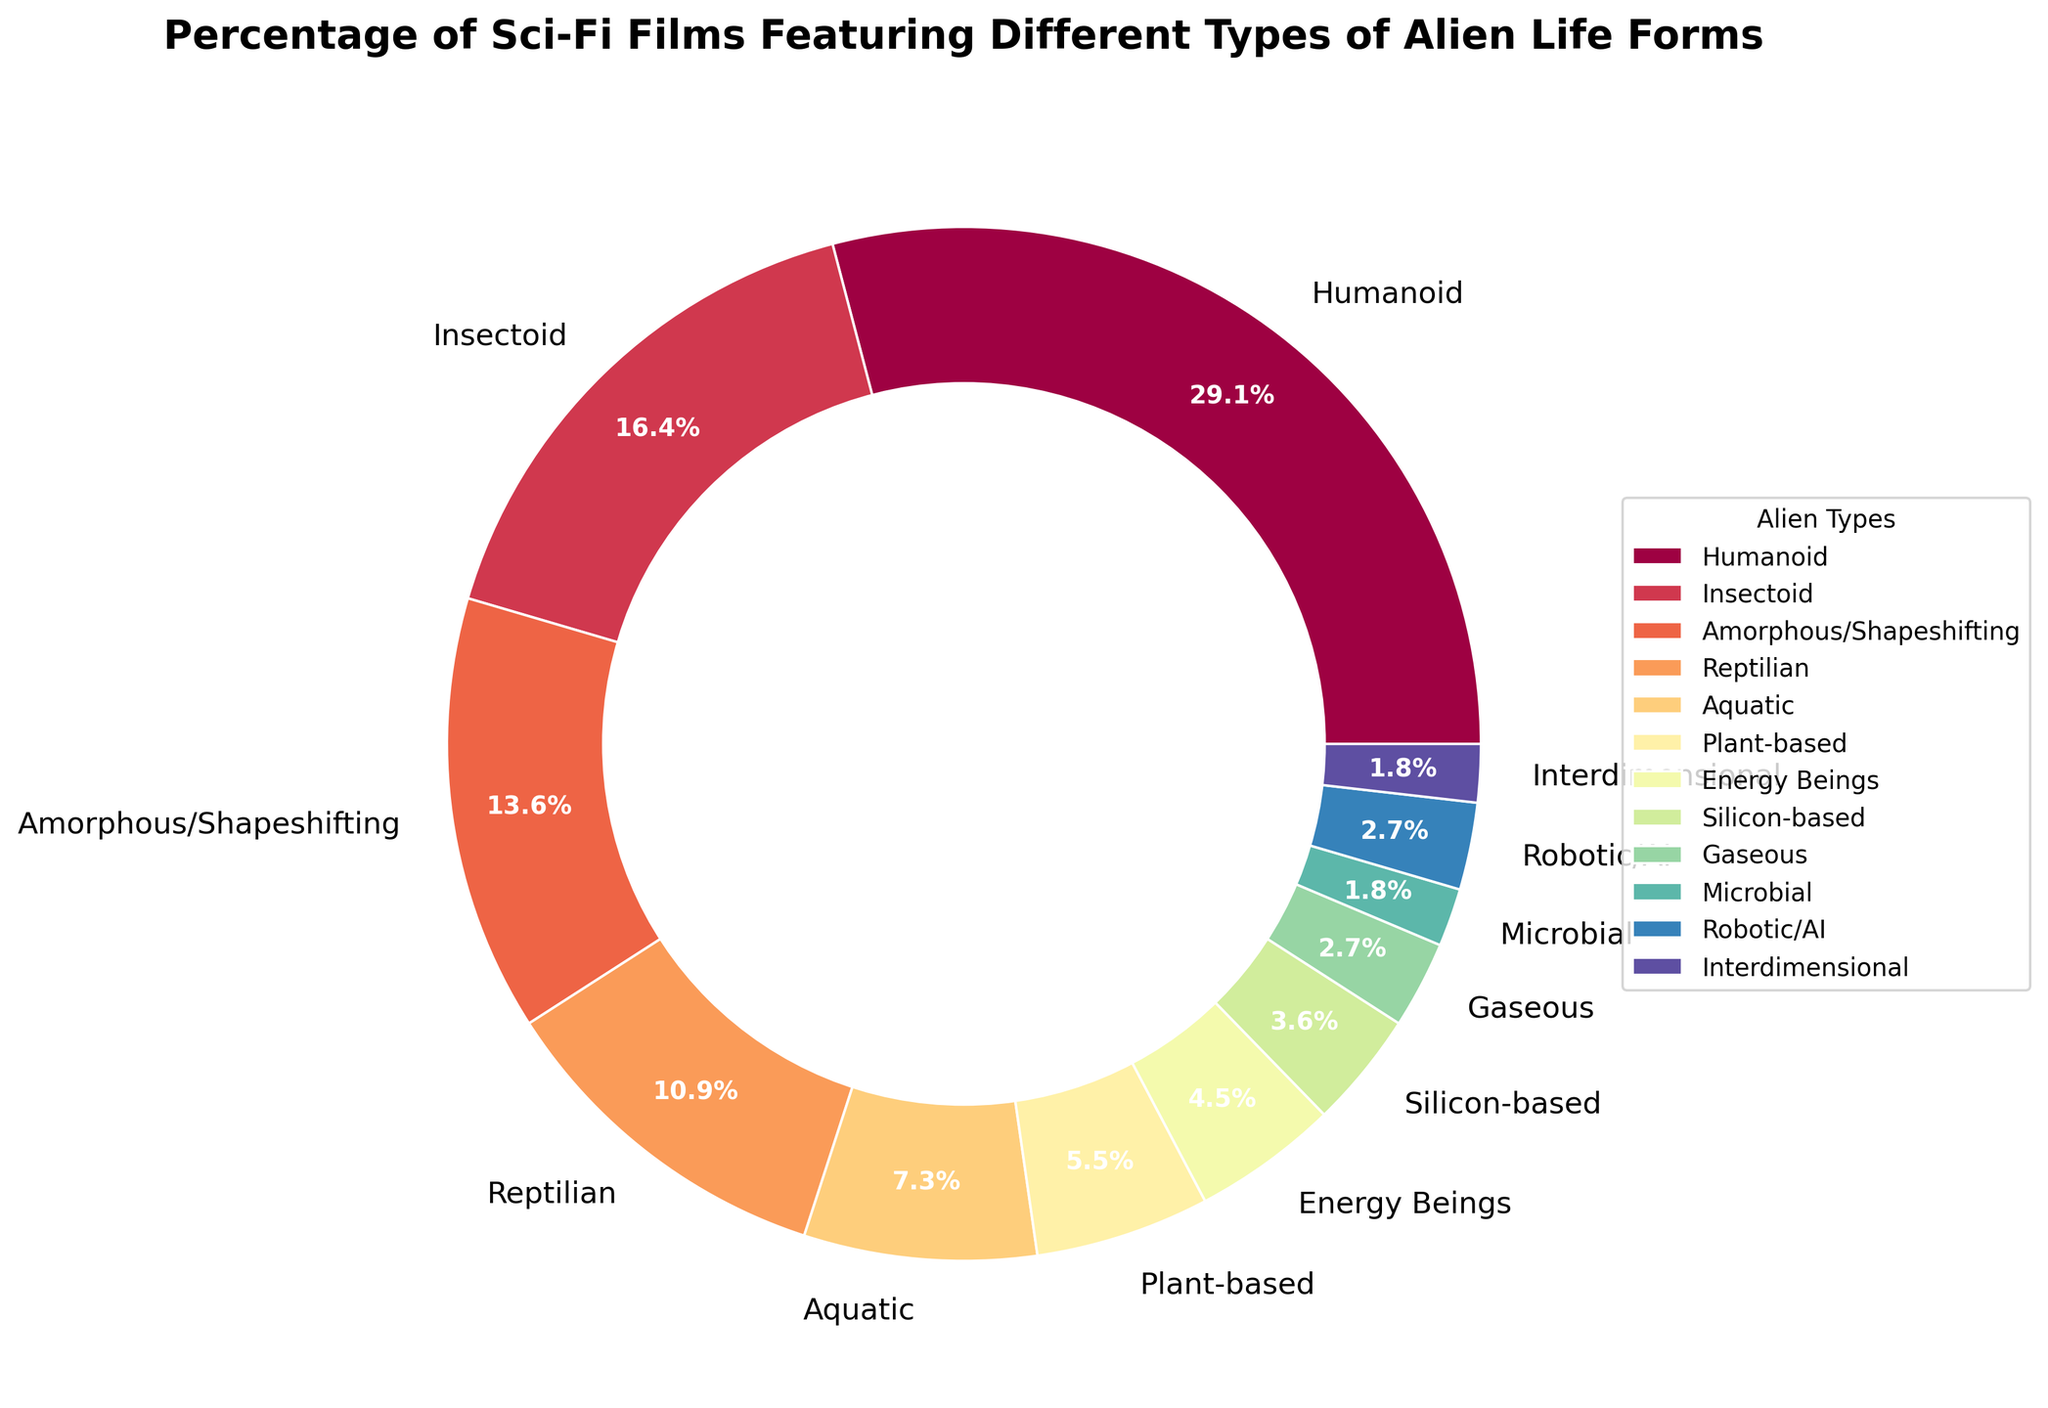What's the highest percentage of a specific type of alien life form featured in sci-fi films? The chart indicates different types of alien life forms and their respective percentages. By looking at the slices of the pie chart, the largest section represents Humanoid aliens with 32%.
Answer: 32% Which two types of alien life forms have similar percentages of appearance, each between 4% and 6%? By examining the chart, we can see that Plant-based and Energy Beings are within the 4%-6% range. Plant-based is 6%, and Energy Beings is 5%.
Answer: Plant-based and Energy Beings How much more prevalent are Humanoid aliens in sci-fi films compared to Reptilian aliens? Humanoid aliens have a percentage of 32%, while Reptilian aliens are at 12%. The difference between these two percentages is 32% - 12% = 20%.
Answer: 20% What's the total percentage of non-corporeal alien life forms shown (e.g., Energy Beings and Gaseous)? Energy Beings have 5% and Gaseous have 3%. Summing these, 5% + 3% = 8%.
Answer: 8% Do Aquatic aliens appear more frequently than Reptilian aliens? Comparing the segments for Aquatic (8%) and Reptilian (12%) life forms, it is evident that Reptilian aliens have a larger percentage.
Answer: No What's the combined percentage of the top three most common alien life forms in sci-fi films? The top three percentages are for Humanoid (32%), Insectoid (18%), and Amorphous/Shapeshifting (15%). Summing these gives: 32% + 18% + 15% = 65%.
Answer: 65% Which type of alien life form is the least frequent in these sci-fi films? The smallest slice of the pie chart represents Microbial aliens with 2%.
Answer: Microbial Considering all alien types with percentages above 10%, calculate their total percentage. The alien types with percentages above 10% are Humanoid (32%), Insectoid (18%), and Amorphous/Shapeshifting (15%), and Reptilian (12%). Summing these yields: 32% + 18% + 15% + 12% = 77%.
Answer: 77% Are there more films featuring Insectoid or Amorphous/Shapeshifting aliens? By comparing the slices, Insectoid aliens have 18% while Amorphous/Shapeshifting have 15%. Thus, Insectoid aliens appear more frequently.
Answer: Insectoid Which alien life form types have a percentage below 5%, and what is their combined percentage? The types below 5% are Silicon-based (4%), Gaseous (3%), Microbial (2%), Robotic/AI (3%), and Interdimensional (2%). Their combined percentage is 4% + 3% + 2% + 3% + 2% = 14%.
Answer: Silicon-based, Gaseous, Microbial, Robotic/AI, Interdimensional, 14% 